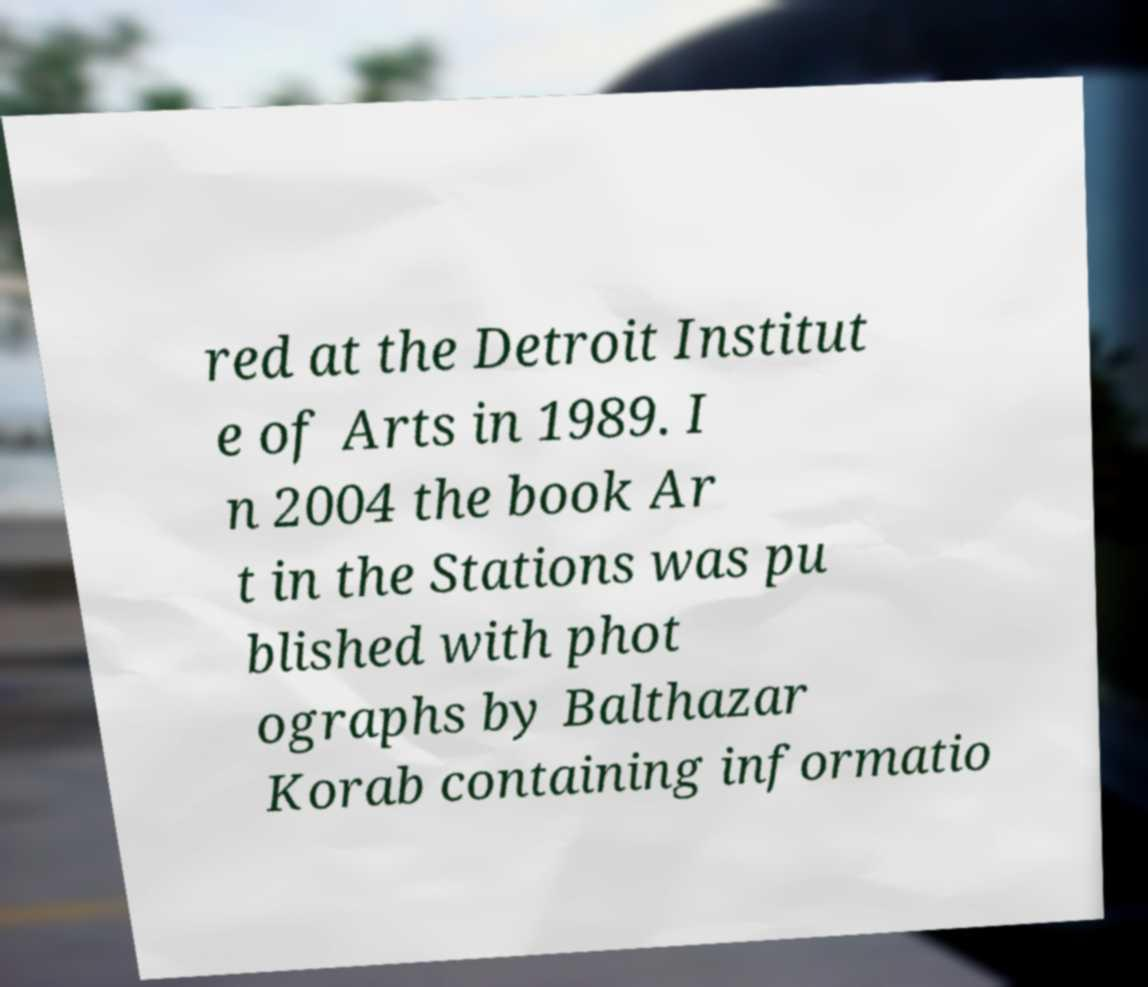I need the written content from this picture converted into text. Can you do that? red at the Detroit Institut e of Arts in 1989. I n 2004 the book Ar t in the Stations was pu blished with phot ographs by Balthazar Korab containing informatio 